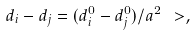<formula> <loc_0><loc_0><loc_500><loc_500>d _ { i } - d _ { j } = ( d _ { i } ^ { 0 } - d _ { j } ^ { 0 } ) / a ^ { 2 } \ > ,</formula> 